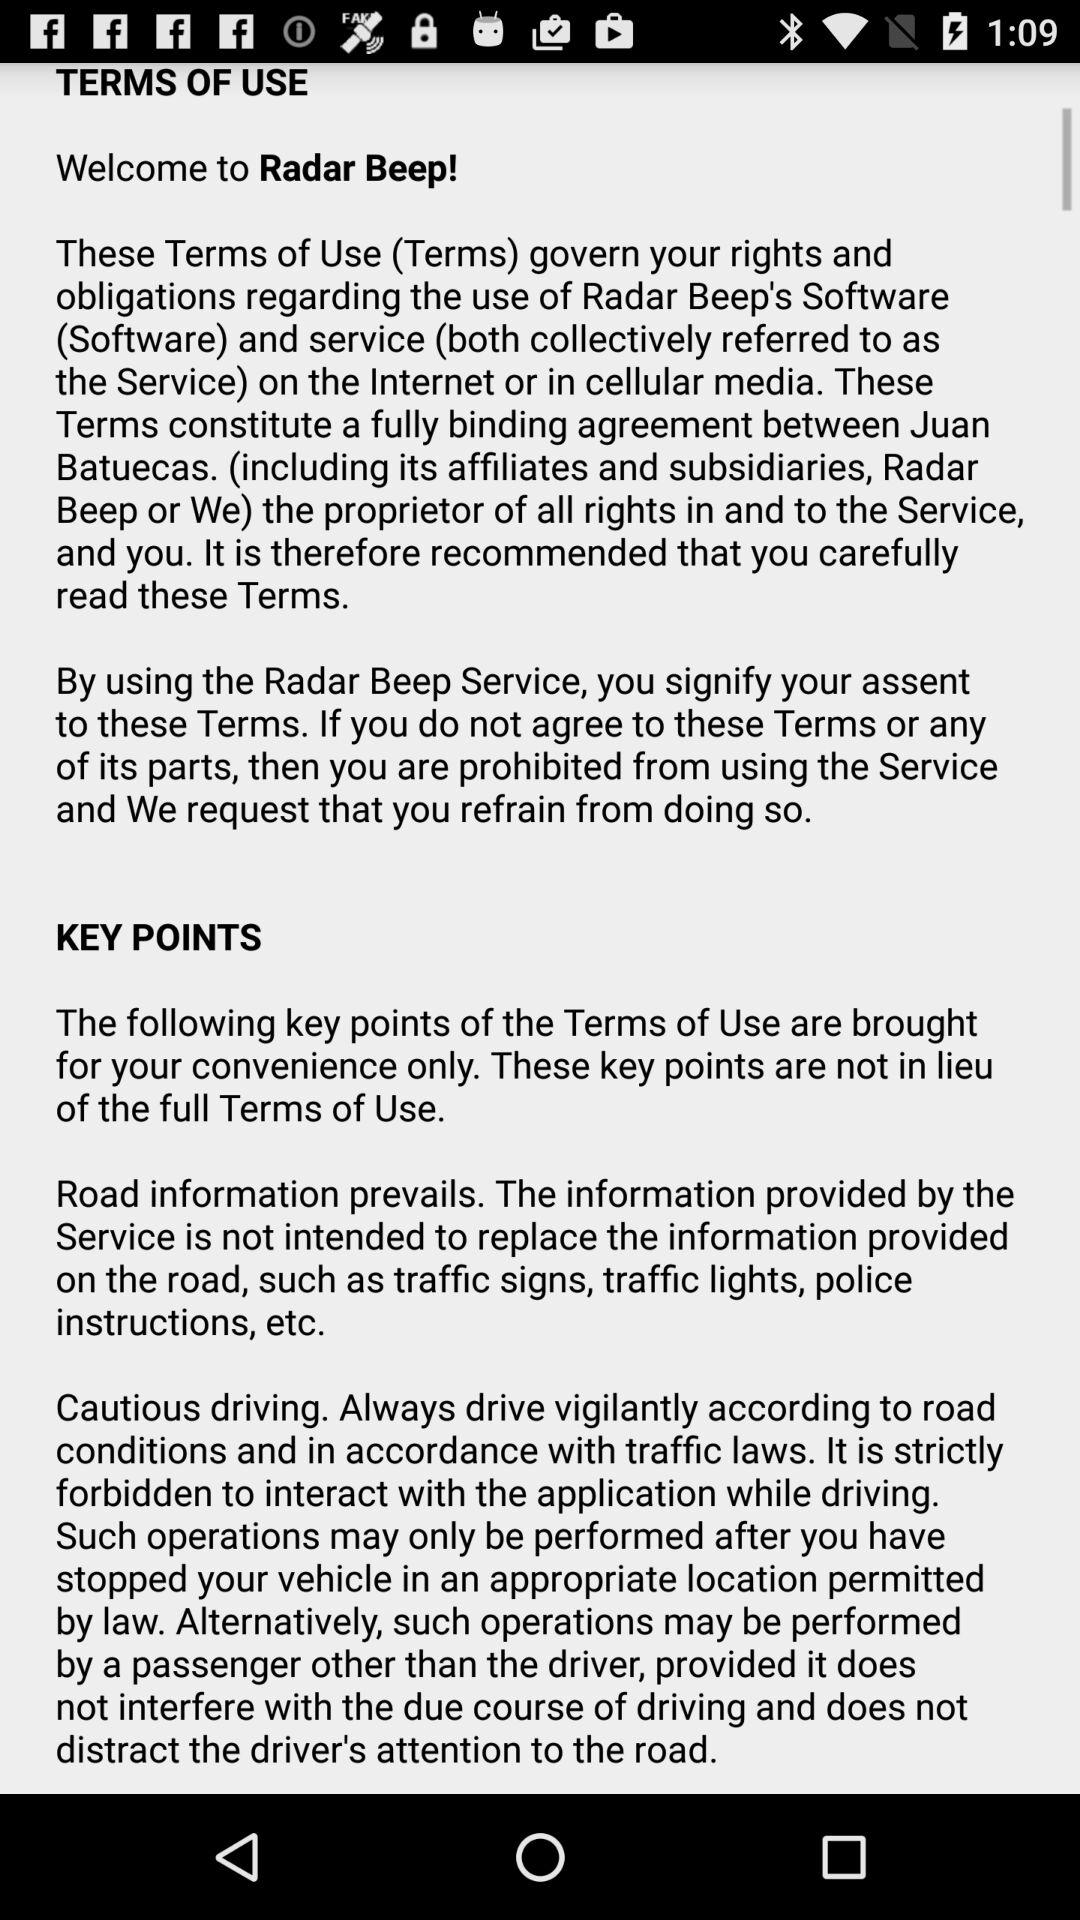What is the application name? The application name is "Radar Beep". 